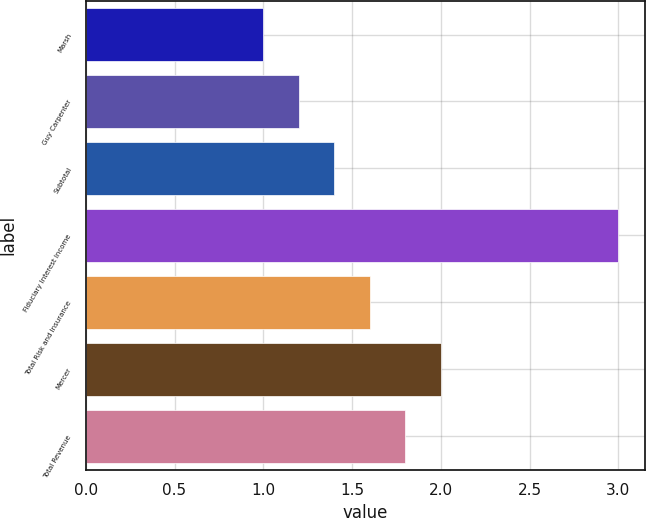Convert chart. <chart><loc_0><loc_0><loc_500><loc_500><bar_chart><fcel>Marsh<fcel>Guy Carpenter<fcel>Subtotal<fcel>Fiduciary Interest Income<fcel>Total Risk and Insurance<fcel>Mercer<fcel>Total Revenue<nl><fcel>1<fcel>1.2<fcel>1.4<fcel>3<fcel>1.6<fcel>2<fcel>1.8<nl></chart> 